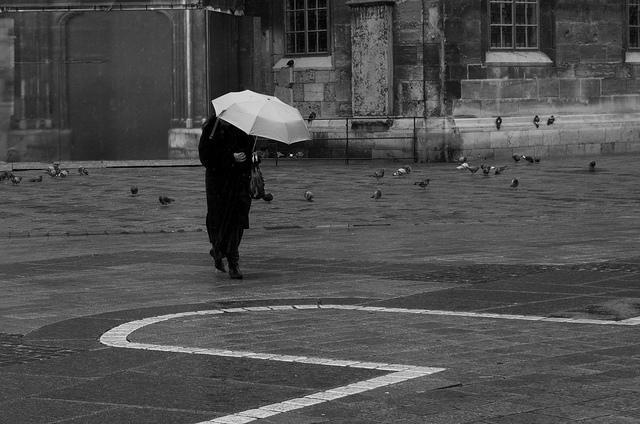How many dogs are there?
Give a very brief answer. 0. 